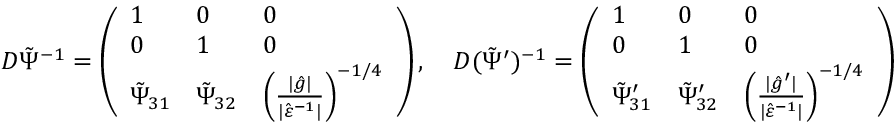<formula> <loc_0><loc_0><loc_500><loc_500>D \tilde { \Psi } ^ { - 1 } = \left ( \begin{array} { l l l } { 1 } & { 0 } & { 0 } \\ { 0 } & { 1 } & { 0 } \\ { \tilde { \Psi } _ { 3 1 } } & { \tilde { \Psi } _ { 3 2 } } & { \left ( \frac { | \hat { g } | } { | \hat { \varepsilon } ^ { - 1 } | } \right ) ^ { - 1 / 4 } } \end{array} \right ) , \quad D ( \tilde { \Psi } ^ { \prime } ) ^ { - 1 } = \left ( \begin{array} { l l l } { 1 } & { 0 } & { 0 } \\ { 0 } & { 1 } & { 0 } \\ { \tilde { \Psi } _ { 3 1 } ^ { \prime } } & { \tilde { \Psi } _ { 3 2 } ^ { \prime } } & { \left ( \frac { | \hat { g } ^ { \prime } | } { | \hat { \varepsilon } ^ { - 1 } | } \right ) ^ { - 1 / 4 } } \end{array} \right )</formula> 